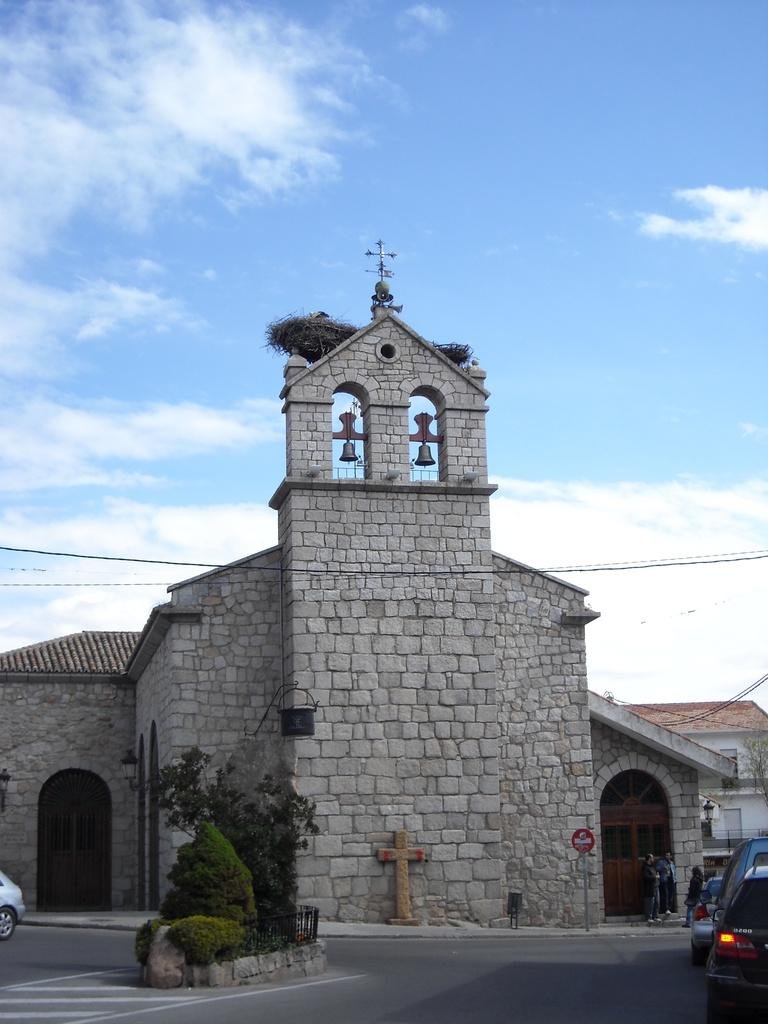What types of objects can be seen in the image? There are vehicles in the image. What type of vegetation is present in the image? There are trees with green color in the image. What can be observed about the people in the image? There are people standing in the image. What can be seen in the distance in the image? There are buildings in the background of the image. What is the color of the sky in the image? The sky is blue and white in color. What type of drug is being discussed by the people in the image? There is no indication of any drug being discussed or present in the image. 